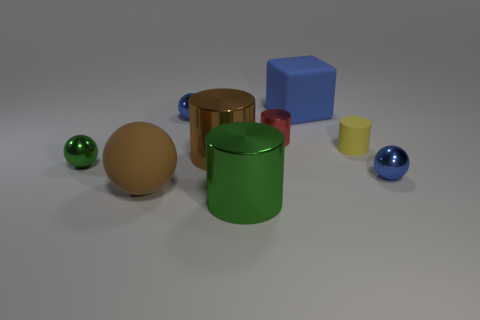Subtract 1 cylinders. How many cylinders are left? 3 Subtract all cylinders. How many objects are left? 5 Subtract 1 red cylinders. How many objects are left? 8 Subtract all brown matte things. Subtract all brown balls. How many objects are left? 7 Add 5 tiny balls. How many tiny balls are left? 8 Add 5 tiny blue metallic spheres. How many tiny blue metallic spheres exist? 7 